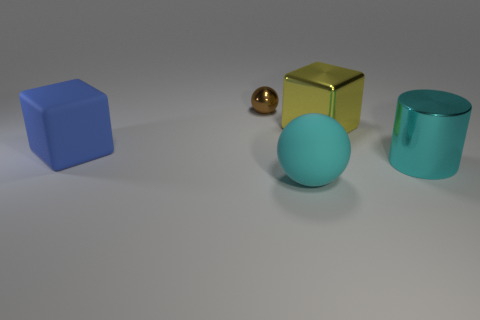Imagine these objects are part of a modern art installation. What message could it be trying to convey? Interpreted as part of a modern art installation, the arrangement and simplicity of the objects could represent the theme of harmony and balance among diverse elements. The variation in shapes - cubes, spheres, and a cylinder - might suggest the uniqueness of individuals, while the cohesive color palette hints at a shared community or environment. The spatial arrangement, with objects not touching, could imply a commentary on personal space or individualism within a society. 